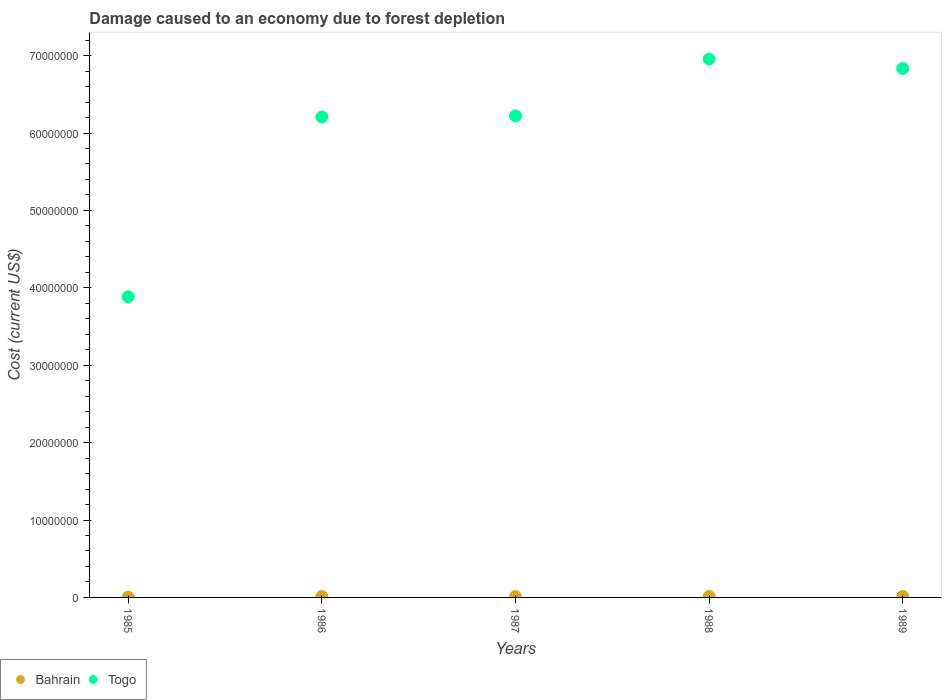What is the cost of damage caused due to forest depletion in Togo in 1988?
Keep it short and to the point. 6.95e+07. Across all years, what is the maximum cost of damage caused due to forest depletion in Togo?
Your response must be concise. 6.95e+07. Across all years, what is the minimum cost of damage caused due to forest depletion in Bahrain?
Ensure brevity in your answer.  3.81e+04. In which year was the cost of damage caused due to forest depletion in Togo minimum?
Provide a short and direct response. 1985. What is the total cost of damage caused due to forest depletion in Bahrain in the graph?
Give a very brief answer. 5.28e+05. What is the difference between the cost of damage caused due to forest depletion in Bahrain in 1986 and that in 1989?
Offer a very short reply. -1.49e+04. What is the difference between the cost of damage caused due to forest depletion in Togo in 1989 and the cost of damage caused due to forest depletion in Bahrain in 1987?
Ensure brevity in your answer.  6.82e+07. What is the average cost of damage caused due to forest depletion in Togo per year?
Provide a succinct answer. 6.02e+07. In the year 1988, what is the difference between the cost of damage caused due to forest depletion in Bahrain and cost of damage caused due to forest depletion in Togo?
Offer a terse response. -6.94e+07. What is the ratio of the cost of damage caused due to forest depletion in Togo in 1986 to that in 1988?
Your response must be concise. 0.89. What is the difference between the highest and the second highest cost of damage caused due to forest depletion in Togo?
Your response must be concise. 1.21e+06. What is the difference between the highest and the lowest cost of damage caused due to forest depletion in Togo?
Give a very brief answer. 3.07e+07. In how many years, is the cost of damage caused due to forest depletion in Togo greater than the average cost of damage caused due to forest depletion in Togo taken over all years?
Provide a short and direct response. 4. Is the sum of the cost of damage caused due to forest depletion in Bahrain in 1987 and 1988 greater than the maximum cost of damage caused due to forest depletion in Togo across all years?
Provide a succinct answer. No. Is the cost of damage caused due to forest depletion in Bahrain strictly greater than the cost of damage caused due to forest depletion in Togo over the years?
Offer a very short reply. No. How many years are there in the graph?
Offer a very short reply. 5. How are the legend labels stacked?
Make the answer very short. Horizontal. What is the title of the graph?
Your response must be concise. Damage caused to an economy due to forest depletion. Does "Turkmenistan" appear as one of the legend labels in the graph?
Offer a very short reply. No. What is the label or title of the X-axis?
Provide a succinct answer. Years. What is the label or title of the Y-axis?
Your answer should be compact. Cost (current US$). What is the Cost (current US$) of Bahrain in 1985?
Offer a very short reply. 3.81e+04. What is the Cost (current US$) in Togo in 1985?
Make the answer very short. 3.88e+07. What is the Cost (current US$) in Bahrain in 1986?
Keep it short and to the point. 1.15e+05. What is the Cost (current US$) in Togo in 1986?
Give a very brief answer. 6.21e+07. What is the Cost (current US$) in Bahrain in 1987?
Provide a short and direct response. 1.22e+05. What is the Cost (current US$) of Togo in 1987?
Your response must be concise. 6.22e+07. What is the Cost (current US$) in Bahrain in 1988?
Make the answer very short. 1.24e+05. What is the Cost (current US$) in Togo in 1988?
Make the answer very short. 6.95e+07. What is the Cost (current US$) of Bahrain in 1989?
Your response must be concise. 1.30e+05. What is the Cost (current US$) in Togo in 1989?
Your answer should be compact. 6.83e+07. Across all years, what is the maximum Cost (current US$) of Bahrain?
Keep it short and to the point. 1.30e+05. Across all years, what is the maximum Cost (current US$) in Togo?
Make the answer very short. 6.95e+07. Across all years, what is the minimum Cost (current US$) in Bahrain?
Offer a terse response. 3.81e+04. Across all years, what is the minimum Cost (current US$) in Togo?
Your response must be concise. 3.88e+07. What is the total Cost (current US$) of Bahrain in the graph?
Offer a very short reply. 5.28e+05. What is the total Cost (current US$) in Togo in the graph?
Make the answer very short. 3.01e+08. What is the difference between the Cost (current US$) in Bahrain in 1985 and that in 1986?
Keep it short and to the point. -7.68e+04. What is the difference between the Cost (current US$) in Togo in 1985 and that in 1986?
Give a very brief answer. -2.32e+07. What is the difference between the Cost (current US$) in Bahrain in 1985 and that in 1987?
Provide a succinct answer. -8.35e+04. What is the difference between the Cost (current US$) of Togo in 1985 and that in 1987?
Provide a succinct answer. -2.34e+07. What is the difference between the Cost (current US$) of Bahrain in 1985 and that in 1988?
Ensure brevity in your answer.  -8.56e+04. What is the difference between the Cost (current US$) in Togo in 1985 and that in 1988?
Your answer should be compact. -3.07e+07. What is the difference between the Cost (current US$) in Bahrain in 1985 and that in 1989?
Make the answer very short. -9.17e+04. What is the difference between the Cost (current US$) of Togo in 1985 and that in 1989?
Offer a terse response. -2.95e+07. What is the difference between the Cost (current US$) of Bahrain in 1986 and that in 1987?
Offer a terse response. -6686.69. What is the difference between the Cost (current US$) in Togo in 1986 and that in 1987?
Keep it short and to the point. -1.45e+05. What is the difference between the Cost (current US$) of Bahrain in 1986 and that in 1988?
Ensure brevity in your answer.  -8778.26. What is the difference between the Cost (current US$) of Togo in 1986 and that in 1988?
Offer a terse response. -7.47e+06. What is the difference between the Cost (current US$) of Bahrain in 1986 and that in 1989?
Keep it short and to the point. -1.49e+04. What is the difference between the Cost (current US$) in Togo in 1986 and that in 1989?
Provide a succinct answer. -6.27e+06. What is the difference between the Cost (current US$) in Bahrain in 1987 and that in 1988?
Ensure brevity in your answer.  -2091.57. What is the difference between the Cost (current US$) of Togo in 1987 and that in 1988?
Keep it short and to the point. -7.33e+06. What is the difference between the Cost (current US$) in Bahrain in 1987 and that in 1989?
Your answer should be compact. -8207.83. What is the difference between the Cost (current US$) in Togo in 1987 and that in 1989?
Provide a short and direct response. -6.12e+06. What is the difference between the Cost (current US$) in Bahrain in 1988 and that in 1989?
Offer a terse response. -6116.26. What is the difference between the Cost (current US$) in Togo in 1988 and that in 1989?
Offer a very short reply. 1.21e+06. What is the difference between the Cost (current US$) in Bahrain in 1985 and the Cost (current US$) in Togo in 1986?
Offer a very short reply. -6.20e+07. What is the difference between the Cost (current US$) in Bahrain in 1985 and the Cost (current US$) in Togo in 1987?
Ensure brevity in your answer.  -6.22e+07. What is the difference between the Cost (current US$) in Bahrain in 1985 and the Cost (current US$) in Togo in 1988?
Provide a succinct answer. -6.95e+07. What is the difference between the Cost (current US$) of Bahrain in 1985 and the Cost (current US$) of Togo in 1989?
Your answer should be compact. -6.83e+07. What is the difference between the Cost (current US$) in Bahrain in 1986 and the Cost (current US$) in Togo in 1987?
Provide a succinct answer. -6.21e+07. What is the difference between the Cost (current US$) in Bahrain in 1986 and the Cost (current US$) in Togo in 1988?
Your answer should be very brief. -6.94e+07. What is the difference between the Cost (current US$) in Bahrain in 1986 and the Cost (current US$) in Togo in 1989?
Your response must be concise. -6.82e+07. What is the difference between the Cost (current US$) in Bahrain in 1987 and the Cost (current US$) in Togo in 1988?
Keep it short and to the point. -6.94e+07. What is the difference between the Cost (current US$) of Bahrain in 1987 and the Cost (current US$) of Togo in 1989?
Offer a terse response. -6.82e+07. What is the difference between the Cost (current US$) in Bahrain in 1988 and the Cost (current US$) in Togo in 1989?
Keep it short and to the point. -6.82e+07. What is the average Cost (current US$) of Bahrain per year?
Your answer should be very brief. 1.06e+05. What is the average Cost (current US$) of Togo per year?
Ensure brevity in your answer.  6.02e+07. In the year 1985, what is the difference between the Cost (current US$) of Bahrain and Cost (current US$) of Togo?
Your response must be concise. -3.88e+07. In the year 1986, what is the difference between the Cost (current US$) of Bahrain and Cost (current US$) of Togo?
Make the answer very short. -6.20e+07. In the year 1987, what is the difference between the Cost (current US$) of Bahrain and Cost (current US$) of Togo?
Make the answer very short. -6.21e+07. In the year 1988, what is the difference between the Cost (current US$) of Bahrain and Cost (current US$) of Togo?
Provide a short and direct response. -6.94e+07. In the year 1989, what is the difference between the Cost (current US$) of Bahrain and Cost (current US$) of Togo?
Give a very brief answer. -6.82e+07. What is the ratio of the Cost (current US$) in Bahrain in 1985 to that in 1986?
Offer a very short reply. 0.33. What is the ratio of the Cost (current US$) of Togo in 1985 to that in 1986?
Your answer should be compact. 0.63. What is the ratio of the Cost (current US$) of Bahrain in 1985 to that in 1987?
Offer a very short reply. 0.31. What is the ratio of the Cost (current US$) of Togo in 1985 to that in 1987?
Offer a very short reply. 0.62. What is the ratio of the Cost (current US$) in Bahrain in 1985 to that in 1988?
Provide a succinct answer. 0.31. What is the ratio of the Cost (current US$) of Togo in 1985 to that in 1988?
Provide a succinct answer. 0.56. What is the ratio of the Cost (current US$) in Bahrain in 1985 to that in 1989?
Offer a terse response. 0.29. What is the ratio of the Cost (current US$) of Togo in 1985 to that in 1989?
Your response must be concise. 0.57. What is the ratio of the Cost (current US$) in Bahrain in 1986 to that in 1987?
Ensure brevity in your answer.  0.94. What is the ratio of the Cost (current US$) in Bahrain in 1986 to that in 1988?
Offer a very short reply. 0.93. What is the ratio of the Cost (current US$) of Togo in 1986 to that in 1988?
Your answer should be compact. 0.89. What is the ratio of the Cost (current US$) in Bahrain in 1986 to that in 1989?
Keep it short and to the point. 0.89. What is the ratio of the Cost (current US$) in Togo in 1986 to that in 1989?
Your response must be concise. 0.91. What is the ratio of the Cost (current US$) in Bahrain in 1987 to that in 1988?
Offer a very short reply. 0.98. What is the ratio of the Cost (current US$) of Togo in 1987 to that in 1988?
Ensure brevity in your answer.  0.89. What is the ratio of the Cost (current US$) in Bahrain in 1987 to that in 1989?
Make the answer very short. 0.94. What is the ratio of the Cost (current US$) of Togo in 1987 to that in 1989?
Provide a succinct answer. 0.91. What is the ratio of the Cost (current US$) in Bahrain in 1988 to that in 1989?
Ensure brevity in your answer.  0.95. What is the ratio of the Cost (current US$) of Togo in 1988 to that in 1989?
Your answer should be compact. 1.02. What is the difference between the highest and the second highest Cost (current US$) in Bahrain?
Your response must be concise. 6116.26. What is the difference between the highest and the second highest Cost (current US$) in Togo?
Provide a short and direct response. 1.21e+06. What is the difference between the highest and the lowest Cost (current US$) in Bahrain?
Your answer should be compact. 9.17e+04. What is the difference between the highest and the lowest Cost (current US$) in Togo?
Offer a very short reply. 3.07e+07. 